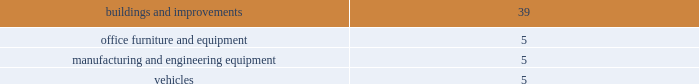
Long-lived assets in accordance with sfas no .
144 , accounting for the impairment or disposal of long-lived assets , the company reviews long-lived assets for impairment whenever events or changes in circumstances indicate the carrying amount of an asset may not be fully recoverable .
The carrying amount of a long-lived asset is not recoverable if it exceeds the sum of the undiscounted cash flows expected to result from the use and eventual disposition of the asset .
That assessment is based on the carrying amount of the asset at the date it is tested for recoverability .
An impairment loss is measured as the amount by which the carrying amount of a long-lived asset exceeds its fair value .
Sfas no .
142 , goodwill and other intangible assets , requires that goodwill and intangible assets with indefinite useful lives should not be amortized but rather be tested for impairment at least annually or sooner whenever events or changes in circumstances indicate that they may be impaired .
The company did not recognize any goodwill or intangible asset impairment charges in 2008 , 2007 , or 2006 .
The company established reporting units based on its current reporting structure .
For purposes of testing goodwill for impairment , goodwill has been allocated to these reporting units to the extent it relates to each reporting unit .
Sfas no .
142 also requires that intangible assets with definite lives be amortized over their estimated useful lives and reviewed for impairment in accordance with sfas no .
144 .
The company is currently amortizing its acquired intangible assets with definite lives over periods ranging from 3 to 10 years .
Dividends on june 6 , 2008 the board of directors declared a dividend of $ 0.75 per share to be paid on december 15 , 2008 to shareholders of record on december 1 , 2008 .
The company paid out a dividend in the amount of $ 150251 .
The dividend has been reported as a reduction of retained earnings .
On august 1 , 2007 the board of directors declared a dividend of $ 0.75 per share to be paid on september 14 , 2007 to shareholders of record on august 15 , 2007 .
The company paid out a dividend in the amount of $ 162531 .
The dividend has been reported as a reduction of retained earnings .
On april 26 , 2006 the board of directors declared a post-split dividend of $ 0.50 per share to be paid on december 15 , 2006 to shareholders of record on december 1 , 2006 .
The company paid out a dividend in the amount of $ 107923 .
The dividend has been reported as a reduction of retained earnings .
Approximately $ 186383 and $ 159210 of retained earnings are indefinitely restricted from distribution to stockholders pursuant to the laws of taiwan at december 27 , 2008 and december 29 , 2007 , respectively .
Intangible assets at december 27 , 2008 and december 29 , 2007 , the company had patents , license agreements , customer related intangibles and other identifiable finite-lived intangible assets recorded at a cost of $ 152104 and $ 159503 , respectively .
The company 2019s excess purchase cost over fair value of net assets acquired ( goodwill ) was $ 127429 at december 27 , 2008 and $ 98494 at december 29 , 2007 .
Identifiable , finite-lived intangible assets are amortized over their estimated useful lives on a straight-line basis over three to ten years .
Accumulated amortization was $ 48579 and $ 59967 at december 27 , 2008 and december 29 , 2007 respectively .
Amortization expense was $ 30874 , $ 26942 , and $ 21147 , for the years ended .
Considering the year 2007 , how many shares belonged to the shareholders? 
Rationale: if the company paid out $ 0.75 per share , then the number of shares of the stockholders is going to be the total amount of dividends paid ( $ 162531 ) divided by $ 0.75 .
Computations: (162531 / 0.75)
Answer: 216708.0. 